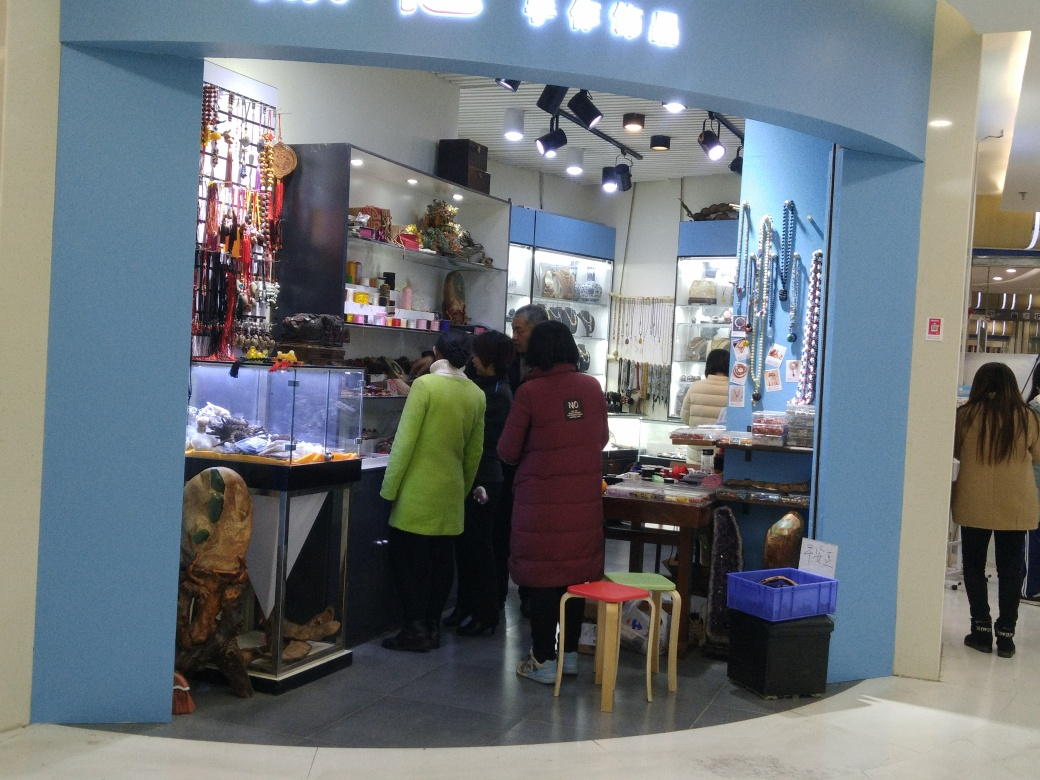Is the overall quality of the image good? The image quality is moderate; it's fairly clear but could benefit from better lighting and focus to enhance visual details such as the items for sale and the expressions of the customers. 